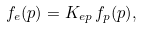Convert formula to latex. <formula><loc_0><loc_0><loc_500><loc_500>f _ { e } ( p ) = K _ { e p } \, f _ { p } ( p ) ,</formula> 